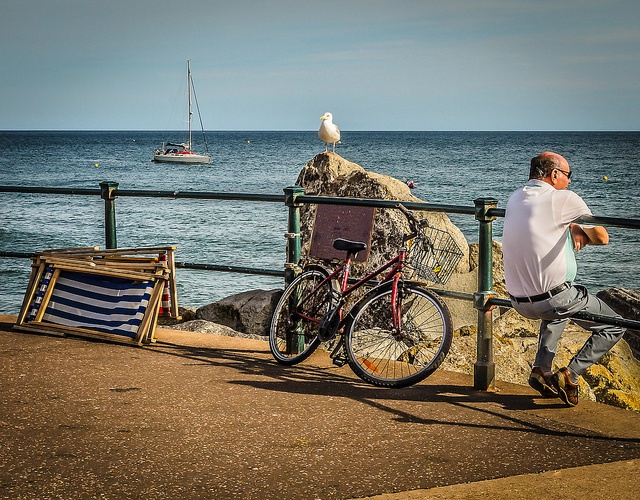Describe the objects in this image and their specific colors. I can see bicycle in gray, black, tan, and maroon tones, people in gray, darkgray, black, and lightgray tones, chair in gray, black, maroon, and darkgray tones, boat in gray, darkgray, lightblue, and blue tones, and chair in gray, black, and maroon tones in this image. 